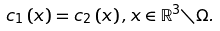Convert formula to latex. <formula><loc_0><loc_0><loc_500><loc_500>c _ { 1 } \left ( x \right ) = c _ { 2 } \left ( x \right ) , x \in \mathbb { R } ^ { 3 } \diagdown \Omega .</formula> 